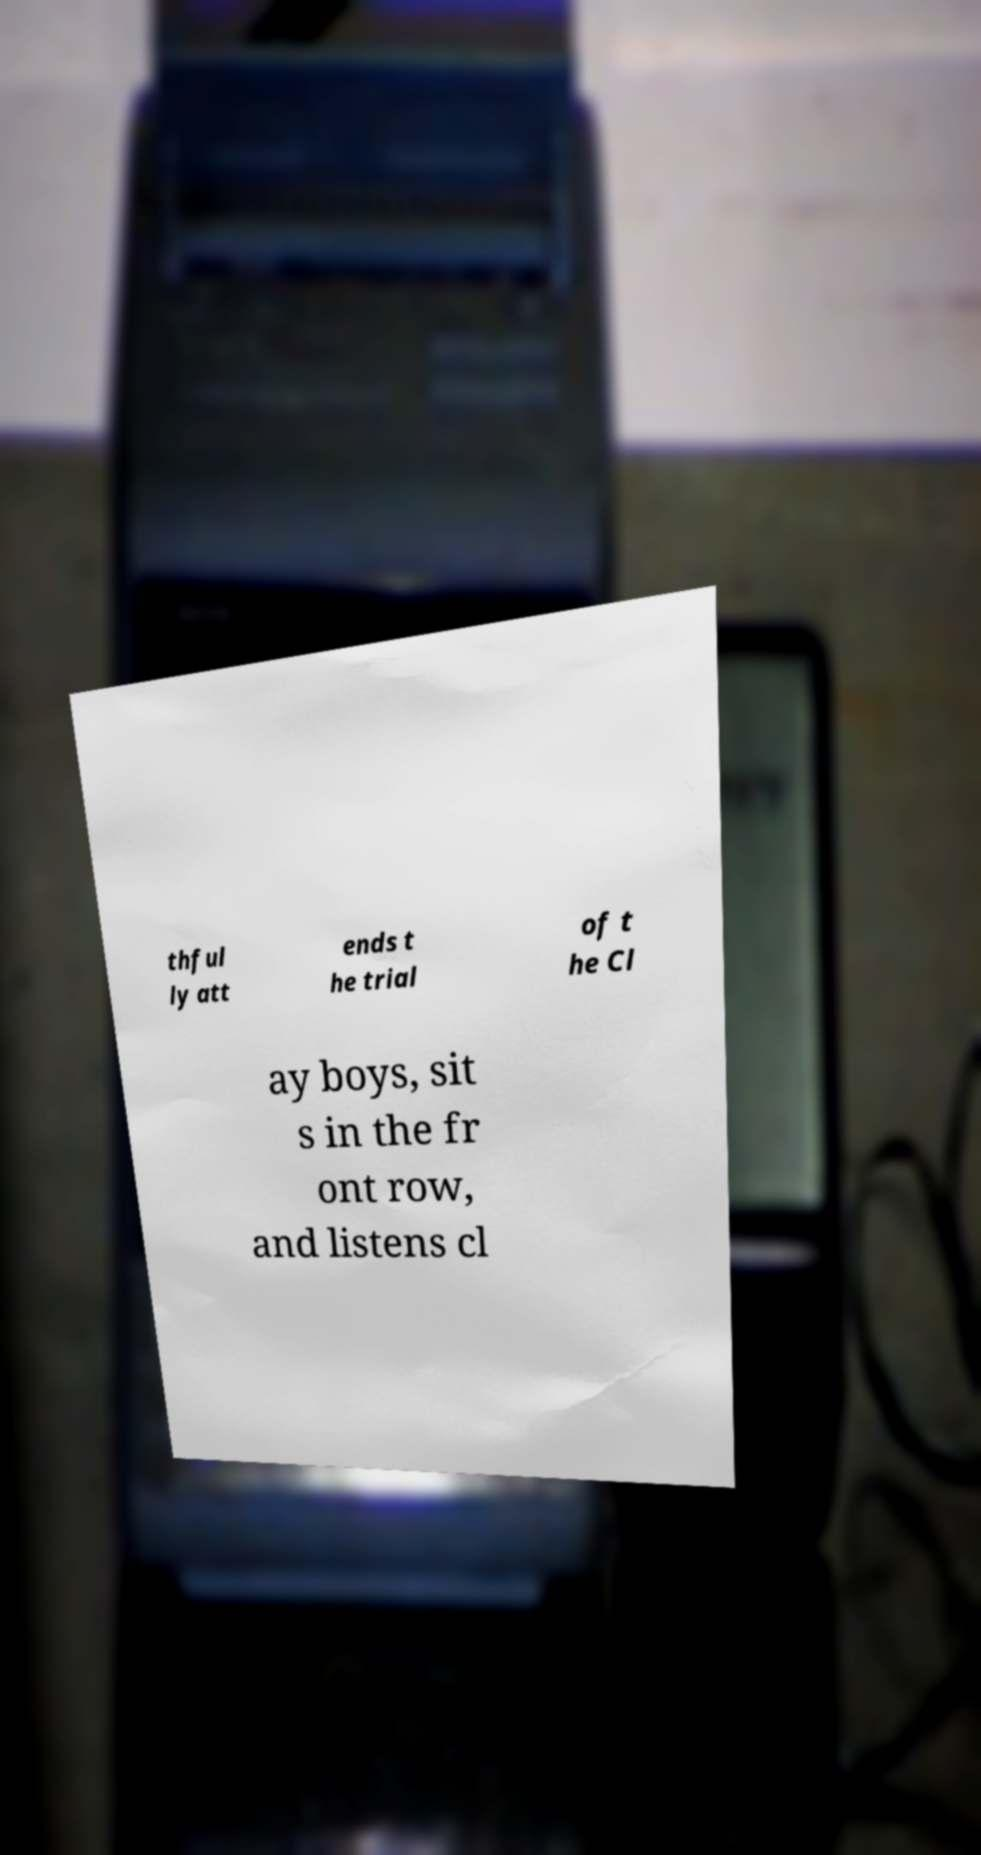Can you read and provide the text displayed in the image?This photo seems to have some interesting text. Can you extract and type it out for me? thful ly att ends t he trial of t he Cl ay boys, sit s in the fr ont row, and listens cl 